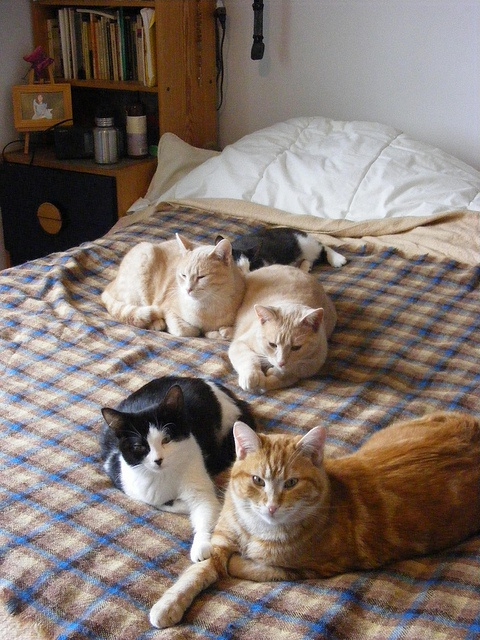Describe the objects in this image and their specific colors. I can see bed in gray, darkgray, and lightgray tones, cat in gray, maroon, and black tones, cat in gray, black, darkgray, and lightgray tones, cat in gray, lightgray, and tan tones, and cat in gray, lightgray, maroon, and darkgray tones in this image. 